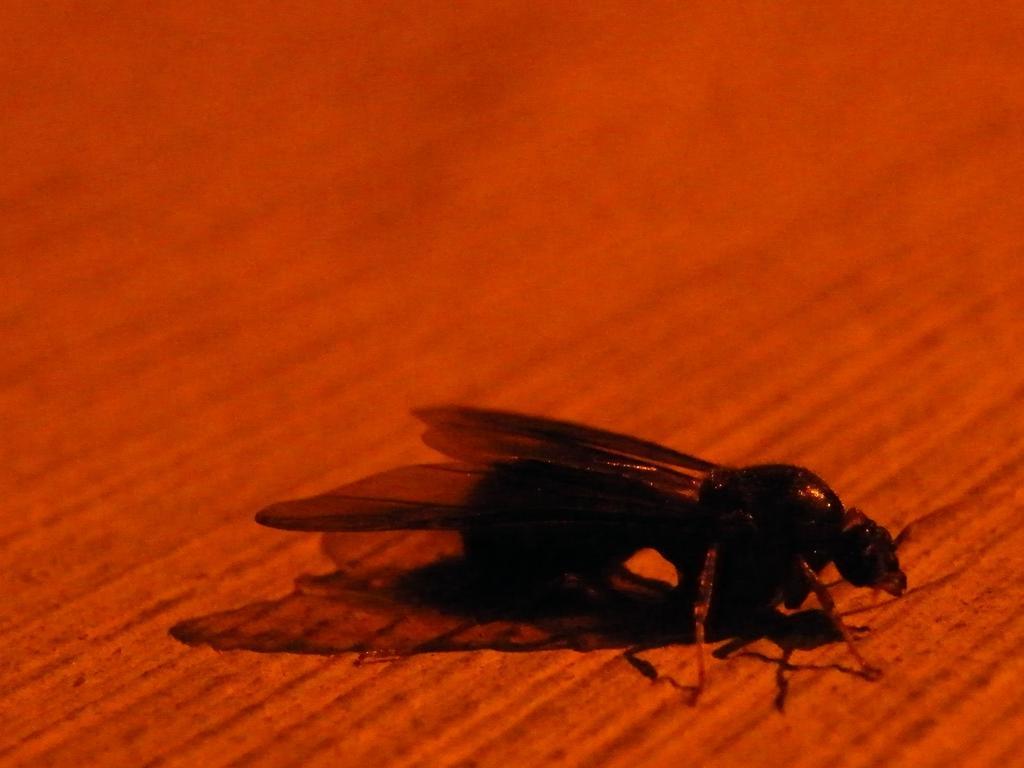Could you give a brief overview of what you see in this image? In this image we can see an insect with wings on a red surface. 